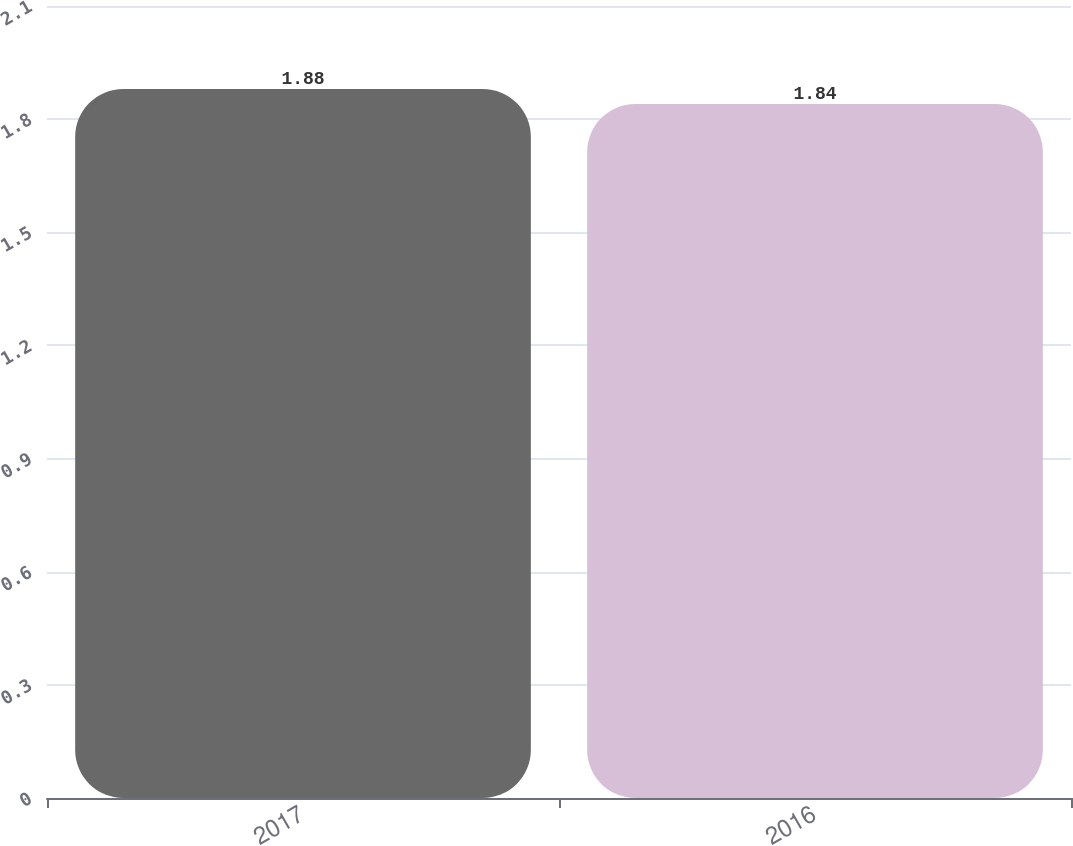Convert chart. <chart><loc_0><loc_0><loc_500><loc_500><bar_chart><fcel>2017<fcel>2016<nl><fcel>1.88<fcel>1.84<nl></chart> 